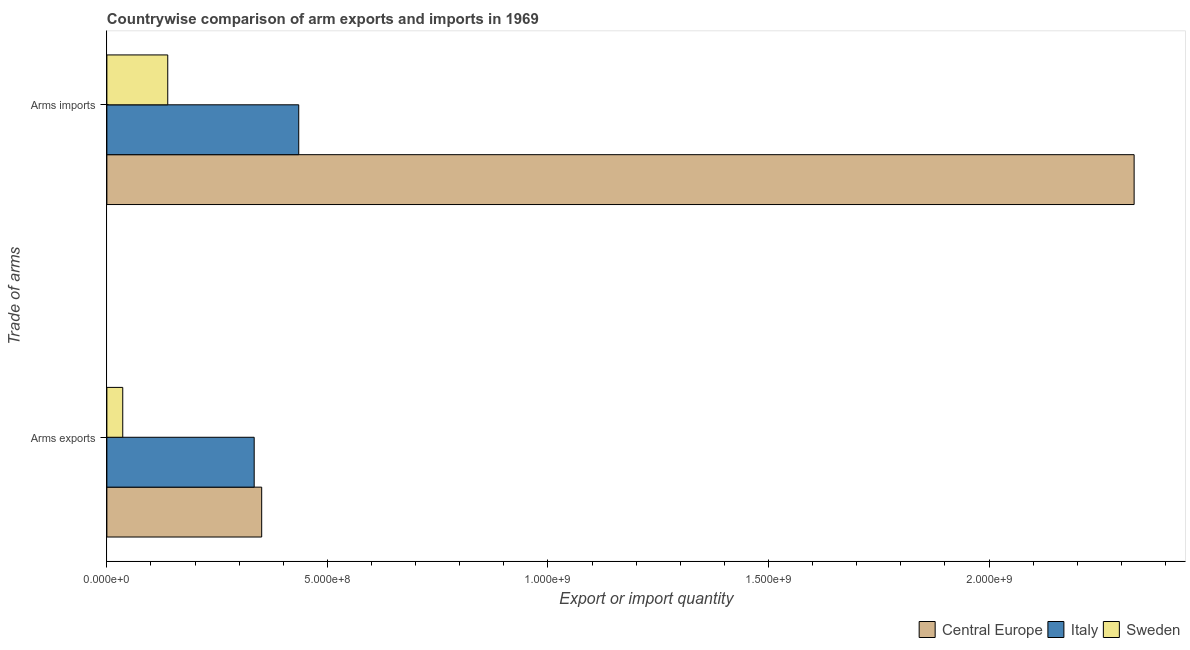Are the number of bars on each tick of the Y-axis equal?
Keep it short and to the point. Yes. What is the label of the 1st group of bars from the top?
Keep it short and to the point. Arms imports. What is the arms exports in Italy?
Your response must be concise. 3.34e+08. Across all countries, what is the maximum arms exports?
Provide a succinct answer. 3.51e+08. Across all countries, what is the minimum arms exports?
Provide a succinct answer. 3.60e+07. In which country was the arms imports maximum?
Keep it short and to the point. Central Europe. In which country was the arms exports minimum?
Provide a short and direct response. Sweden. What is the total arms imports in the graph?
Your response must be concise. 2.90e+09. What is the difference between the arms imports in Central Europe and that in Italy?
Provide a short and direct response. 1.89e+09. What is the difference between the arms exports in Central Europe and the arms imports in Sweden?
Your response must be concise. 2.13e+08. What is the average arms imports per country?
Give a very brief answer. 9.67e+08. What is the difference between the arms exports and arms imports in Central Europe?
Provide a short and direct response. -1.98e+09. What is the ratio of the arms imports in Central Europe to that in Sweden?
Your answer should be very brief. 16.88. Is the arms imports in Sweden less than that in Central Europe?
Offer a terse response. Yes. In how many countries, is the arms imports greater than the average arms imports taken over all countries?
Offer a very short reply. 1. What does the 3rd bar from the top in Arms exports represents?
Offer a terse response. Central Europe. What does the 1st bar from the bottom in Arms exports represents?
Ensure brevity in your answer.  Central Europe. What is the difference between two consecutive major ticks on the X-axis?
Provide a short and direct response. 5.00e+08. Are the values on the major ticks of X-axis written in scientific E-notation?
Ensure brevity in your answer.  Yes. Does the graph contain any zero values?
Your response must be concise. No. Does the graph contain grids?
Your answer should be very brief. No. How many legend labels are there?
Make the answer very short. 3. What is the title of the graph?
Provide a short and direct response. Countrywise comparison of arm exports and imports in 1969. Does "Congo (Democratic)" appear as one of the legend labels in the graph?
Make the answer very short. No. What is the label or title of the X-axis?
Provide a succinct answer. Export or import quantity. What is the label or title of the Y-axis?
Your answer should be very brief. Trade of arms. What is the Export or import quantity of Central Europe in Arms exports?
Give a very brief answer. 3.51e+08. What is the Export or import quantity in Italy in Arms exports?
Ensure brevity in your answer.  3.34e+08. What is the Export or import quantity of Sweden in Arms exports?
Provide a succinct answer. 3.60e+07. What is the Export or import quantity of Central Europe in Arms imports?
Give a very brief answer. 2.33e+09. What is the Export or import quantity of Italy in Arms imports?
Ensure brevity in your answer.  4.35e+08. What is the Export or import quantity in Sweden in Arms imports?
Provide a short and direct response. 1.38e+08. Across all Trade of arms, what is the maximum Export or import quantity in Central Europe?
Provide a succinct answer. 2.33e+09. Across all Trade of arms, what is the maximum Export or import quantity in Italy?
Your answer should be very brief. 4.35e+08. Across all Trade of arms, what is the maximum Export or import quantity of Sweden?
Your answer should be very brief. 1.38e+08. Across all Trade of arms, what is the minimum Export or import quantity of Central Europe?
Offer a very short reply. 3.51e+08. Across all Trade of arms, what is the minimum Export or import quantity in Italy?
Ensure brevity in your answer.  3.34e+08. Across all Trade of arms, what is the minimum Export or import quantity of Sweden?
Ensure brevity in your answer.  3.60e+07. What is the total Export or import quantity in Central Europe in the graph?
Your answer should be very brief. 2.68e+09. What is the total Export or import quantity in Italy in the graph?
Provide a succinct answer. 7.69e+08. What is the total Export or import quantity of Sweden in the graph?
Your answer should be very brief. 1.74e+08. What is the difference between the Export or import quantity of Central Europe in Arms exports and that in Arms imports?
Your answer should be very brief. -1.98e+09. What is the difference between the Export or import quantity in Italy in Arms exports and that in Arms imports?
Your answer should be compact. -1.01e+08. What is the difference between the Export or import quantity of Sweden in Arms exports and that in Arms imports?
Your answer should be very brief. -1.02e+08. What is the difference between the Export or import quantity of Central Europe in Arms exports and the Export or import quantity of Italy in Arms imports?
Offer a terse response. -8.40e+07. What is the difference between the Export or import quantity of Central Europe in Arms exports and the Export or import quantity of Sweden in Arms imports?
Ensure brevity in your answer.  2.13e+08. What is the difference between the Export or import quantity of Italy in Arms exports and the Export or import quantity of Sweden in Arms imports?
Offer a very short reply. 1.96e+08. What is the average Export or import quantity of Central Europe per Trade of arms?
Keep it short and to the point. 1.34e+09. What is the average Export or import quantity in Italy per Trade of arms?
Give a very brief answer. 3.84e+08. What is the average Export or import quantity in Sweden per Trade of arms?
Give a very brief answer. 8.70e+07. What is the difference between the Export or import quantity of Central Europe and Export or import quantity of Italy in Arms exports?
Make the answer very short. 1.70e+07. What is the difference between the Export or import quantity of Central Europe and Export or import quantity of Sweden in Arms exports?
Offer a terse response. 3.15e+08. What is the difference between the Export or import quantity in Italy and Export or import quantity in Sweden in Arms exports?
Make the answer very short. 2.98e+08. What is the difference between the Export or import quantity in Central Europe and Export or import quantity in Italy in Arms imports?
Offer a terse response. 1.89e+09. What is the difference between the Export or import quantity in Central Europe and Export or import quantity in Sweden in Arms imports?
Make the answer very short. 2.19e+09. What is the difference between the Export or import quantity in Italy and Export or import quantity in Sweden in Arms imports?
Your answer should be very brief. 2.97e+08. What is the ratio of the Export or import quantity in Central Europe in Arms exports to that in Arms imports?
Ensure brevity in your answer.  0.15. What is the ratio of the Export or import quantity in Italy in Arms exports to that in Arms imports?
Your answer should be very brief. 0.77. What is the ratio of the Export or import quantity of Sweden in Arms exports to that in Arms imports?
Keep it short and to the point. 0.26. What is the difference between the highest and the second highest Export or import quantity in Central Europe?
Your answer should be very brief. 1.98e+09. What is the difference between the highest and the second highest Export or import quantity of Italy?
Ensure brevity in your answer.  1.01e+08. What is the difference between the highest and the second highest Export or import quantity in Sweden?
Provide a short and direct response. 1.02e+08. What is the difference between the highest and the lowest Export or import quantity in Central Europe?
Offer a very short reply. 1.98e+09. What is the difference between the highest and the lowest Export or import quantity in Italy?
Your answer should be very brief. 1.01e+08. What is the difference between the highest and the lowest Export or import quantity of Sweden?
Ensure brevity in your answer.  1.02e+08. 